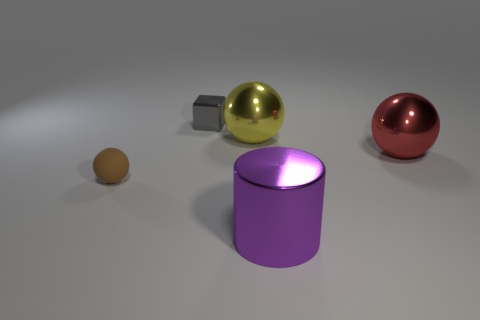There is a small object left of the tiny metallic block; is its color the same as the large cylinder?
Your answer should be compact. No. What is the shape of the metallic thing behind the metal sphere left of the red metal object?
Give a very brief answer. Cube. Is there a purple rubber cylinder that has the same size as the purple metallic cylinder?
Ensure brevity in your answer.  No. Are there fewer yellow metallic balls than large metal spheres?
Offer a terse response. Yes. The big metallic thing in front of the thing that is right of the object that is in front of the small brown rubber object is what shape?
Make the answer very short. Cylinder. How many objects are large purple metal objects on the right side of the small brown matte sphere or large objects that are in front of the small matte thing?
Offer a terse response. 1. There is a big red metallic ball; are there any purple metal cylinders behind it?
Offer a very short reply. No. How many objects are either spheres on the right side of the shiny block or small gray cubes?
Your answer should be very brief. 3. What number of brown objects are either large metallic cylinders or rubber things?
Provide a short and direct response. 1. What number of other objects are the same color as the cylinder?
Give a very brief answer. 0. 